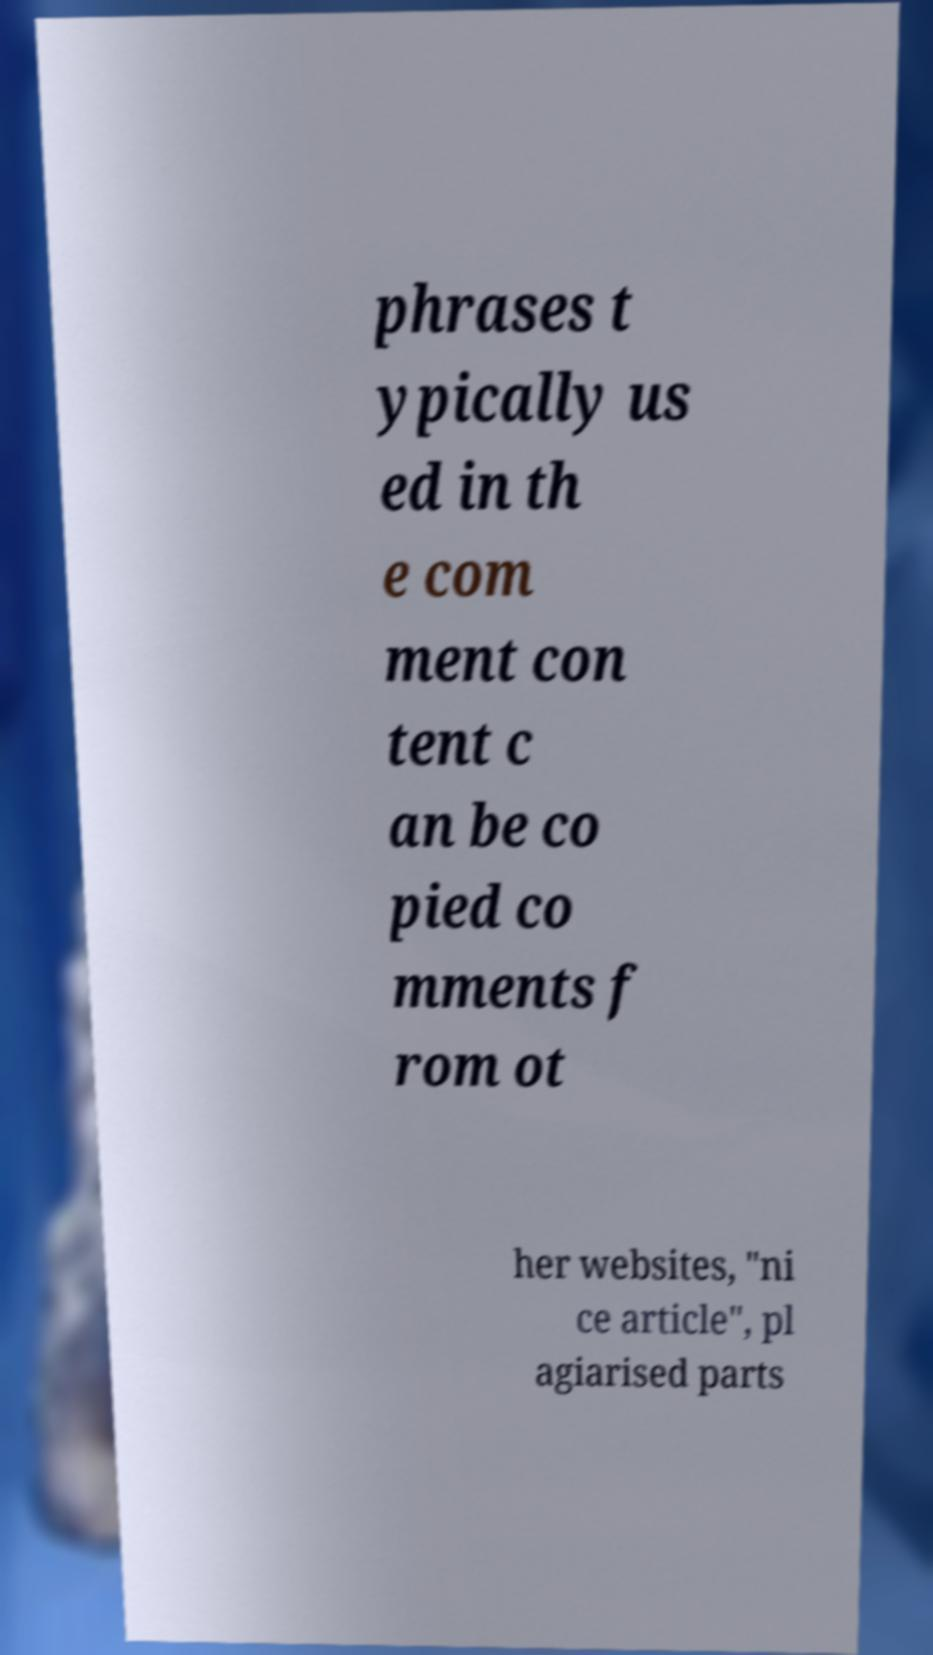Please identify and transcribe the text found in this image. phrases t ypically us ed in th e com ment con tent c an be co pied co mments f rom ot her websites, "ni ce article", pl agiarised parts 